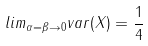Convert formula to latex. <formula><loc_0><loc_0><loc_500><loc_500>l i m _ { \alpha = \beta \rightarrow 0 } v a r ( X ) = \frac { 1 } { 4 }</formula> 